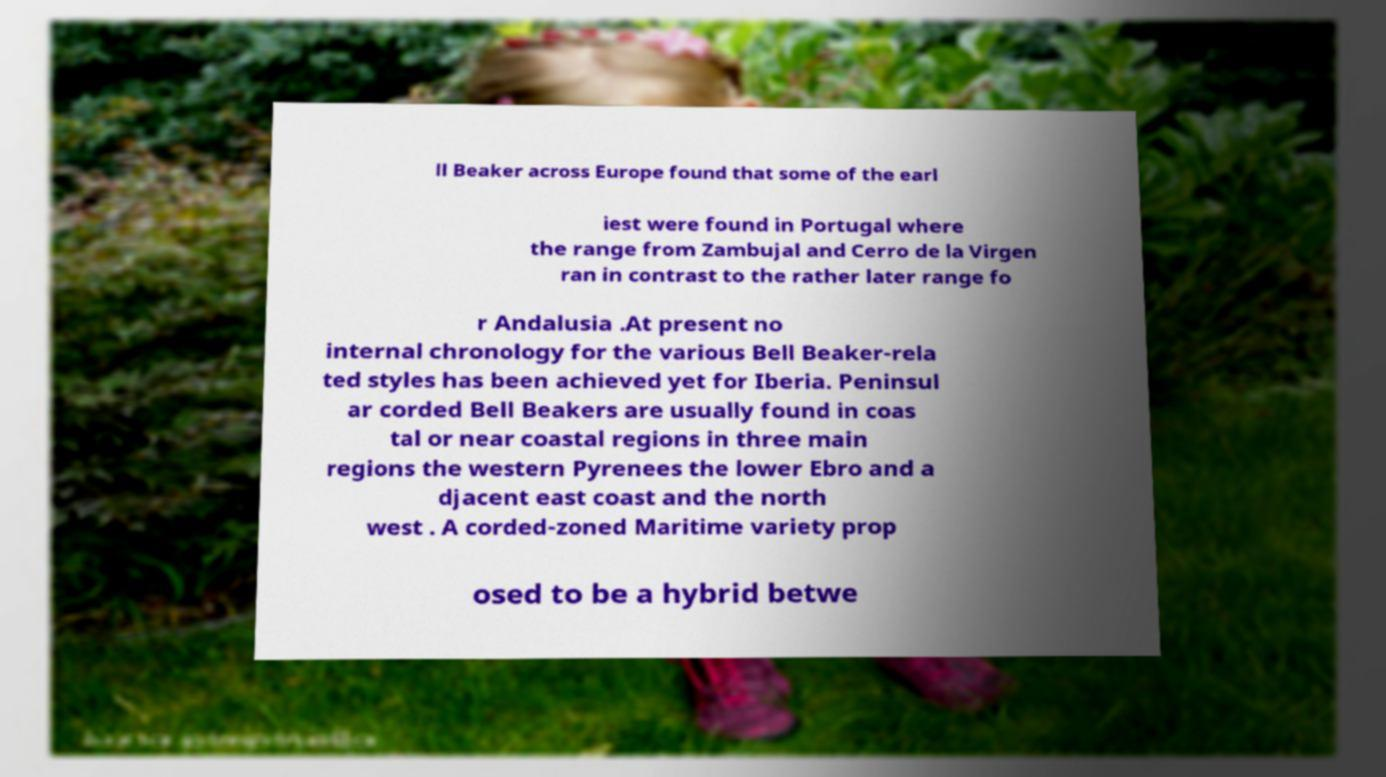Please read and relay the text visible in this image. What does it say? ll Beaker across Europe found that some of the earl iest were found in Portugal where the range from Zambujal and Cerro de la Virgen ran in contrast to the rather later range fo r Andalusia .At present no internal chronology for the various Bell Beaker-rela ted styles has been achieved yet for Iberia. Peninsul ar corded Bell Beakers are usually found in coas tal or near coastal regions in three main regions the western Pyrenees the lower Ebro and a djacent east coast and the north west . A corded-zoned Maritime variety prop osed to be a hybrid betwe 